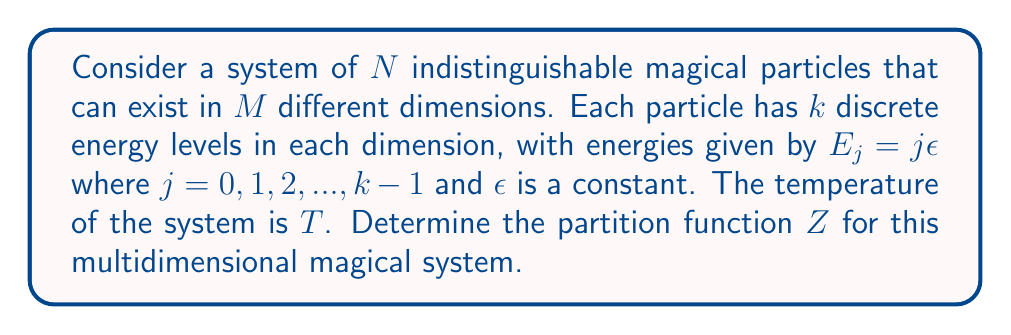Provide a solution to this math problem. To solve this problem, we'll follow these steps:

1) The partition function for a single particle in one dimension is:

   $$Z_1 = \sum_{j=0}^{k-1} e^{-\beta E_j} = \sum_{j=0}^{k-1} e^{-\beta j\epsilon}$$

   where $\beta = \frac{1}{k_B T}$, and $k_B$ is Boltzmann's constant.

2) This sum is a geometric series with $k$ terms. The sum of a geometric series is given by:

   $$\sum_{j=0}^{k-1} ar^j = a\frac{1-r^k}{1-r}$$

   where $a = 1$ and $r = e^{-\beta\epsilon}$ in our case.

3) Therefore, for a single particle in one dimension:

   $$Z_1 = \frac{1-e^{-\beta k\epsilon}}{1-e^{-\beta\epsilon}}$$

4) For a single particle in $M$ dimensions, the partition function is:

   $$Z_1^M = \left(\frac{1-e^{-\beta k\epsilon}}{1-e^{-\beta\epsilon}}\right)^M$$

5) For $N$ indistinguishable particles, we divide by $N!$ to avoid overcounting:

   $$Z = \frac{1}{N!}\left(Z_1^M\right)^N = \frac{1}{N!}\left(\frac{1-e^{-\beta k\epsilon}}{1-e^{-\beta\epsilon}}\right)^{MN}$$

This is the partition function for the system of $N$ indistinguishable magical particles in $M$ dimensions.
Answer: $$Z = \frac{1}{N!}\left(\frac{1-e^{-\beta k\epsilon}}{1-e^{-\beta\epsilon}}\right)^{MN}$$ 